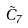Convert formula to latex. <formula><loc_0><loc_0><loc_500><loc_500>\tilde { C } _ { 7 }</formula> 